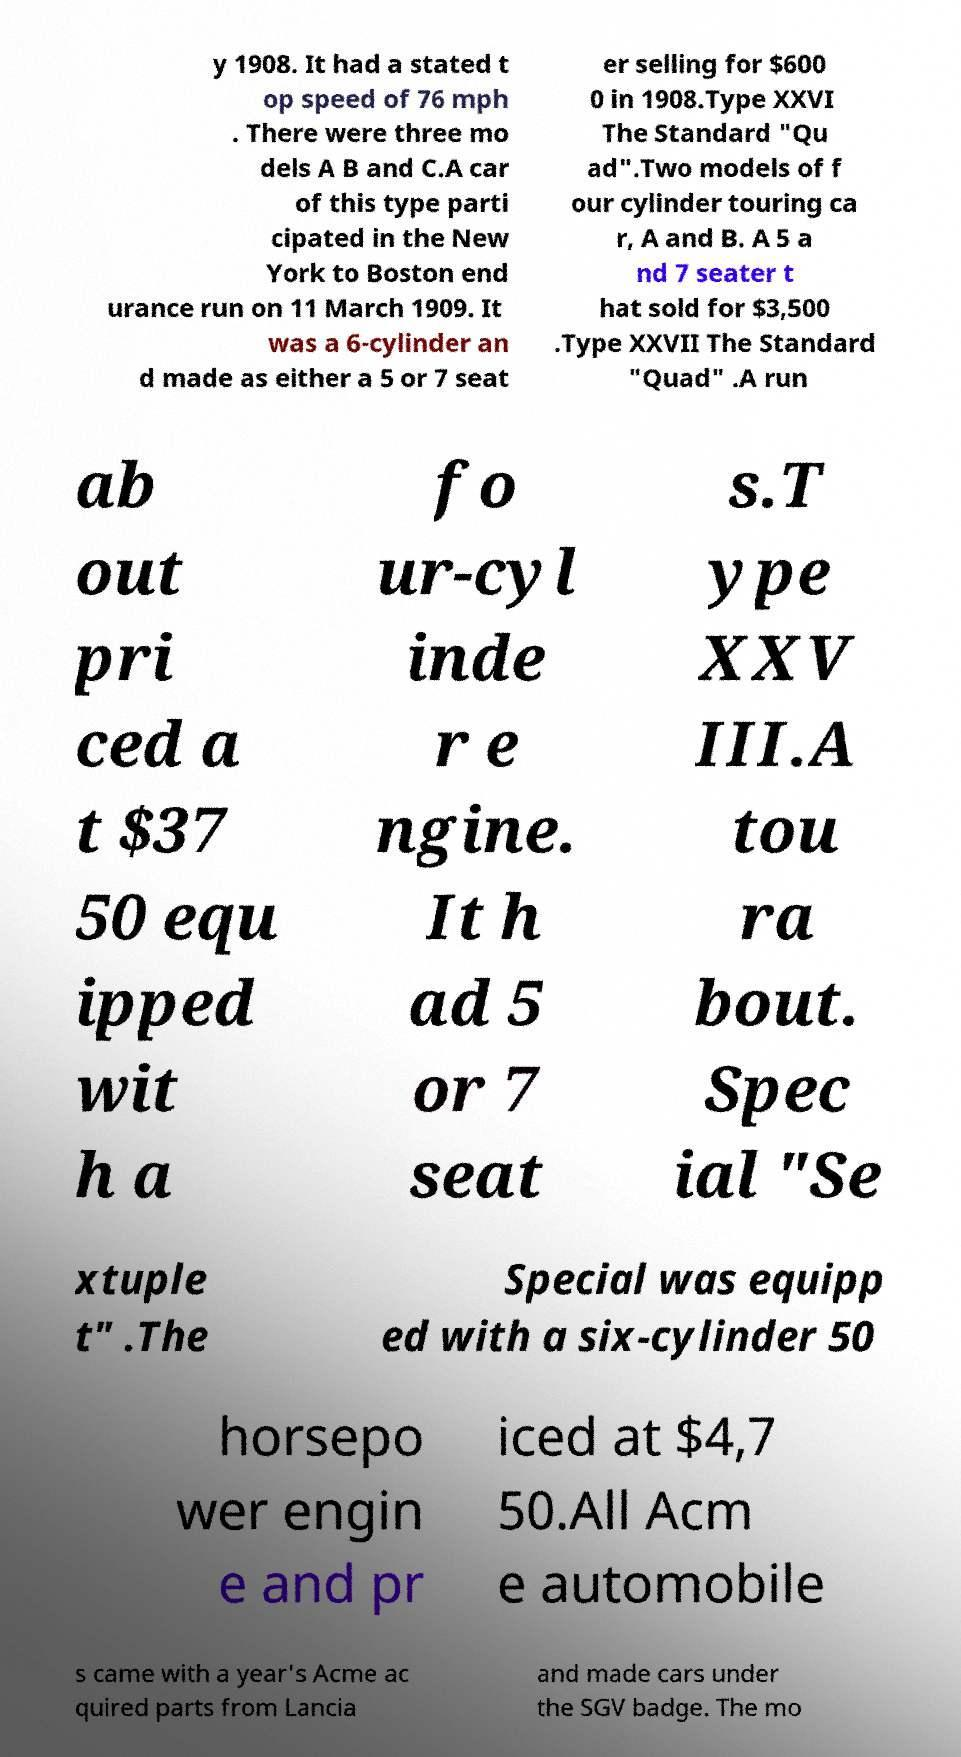Please read and relay the text visible in this image. What does it say? y 1908. It had a stated t op speed of 76 mph . There were three mo dels A B and C.A car of this type parti cipated in the New York to Boston end urance run on 11 March 1909. It was a 6-cylinder an d made as either a 5 or 7 seat er selling for $600 0 in 1908.Type XXVI The Standard "Qu ad".Two models of f our cylinder touring ca r, A and B. A 5 a nd 7 seater t hat sold for $3,500 .Type XXVII The Standard "Quad" .A run ab out pri ced a t $37 50 equ ipped wit h a fo ur-cyl inde r e ngine. It h ad 5 or 7 seat s.T ype XXV III.A tou ra bout. Spec ial "Se xtuple t" .The Special was equipp ed with a six-cylinder 50 horsepo wer engin e and pr iced at $4,7 50.All Acm e automobile s came with a year's Acme ac quired parts from Lancia and made cars under the SGV badge. The mo 